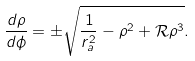<formula> <loc_0><loc_0><loc_500><loc_500>\frac { d \rho } { d \phi } = \pm \sqrt { \frac { 1 } { r _ { a } ^ { 2 } } - \rho ^ { 2 } + \mathcal { R } \rho ^ { 3 } } .</formula> 